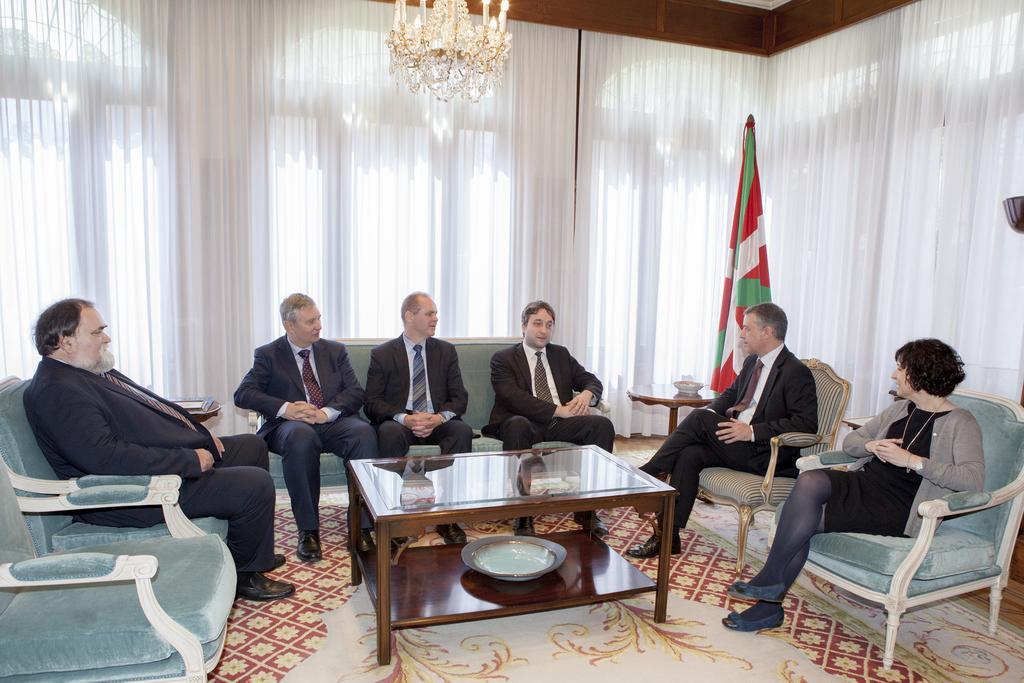Describe this image in one or two sentences. This is a room in which there are six people among them five are men and one is a women and the walls are covered with the white curtain and there is table in front of them on the floor mat and a lamb to the roof and a flag on the right side and all the men are in black suit. 